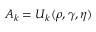<formula> <loc_0><loc_0><loc_500><loc_500>A _ { k } = U _ { k } ( \rho , \gamma , \eta )</formula> 